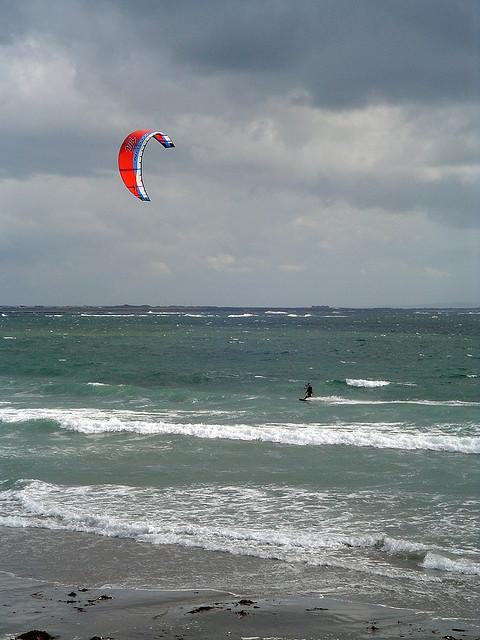What type of clouds are in the sky of this picture?
Keep it brief. Nimbus. How is the sea?
Concise answer only. Rough. How many people are pictured?
Short answer required. 1. Is there a mountain in the background?
Answer briefly. No. Is this a beach?
Answer briefly. Yes. What color is the flag?
Answer briefly. Red. 